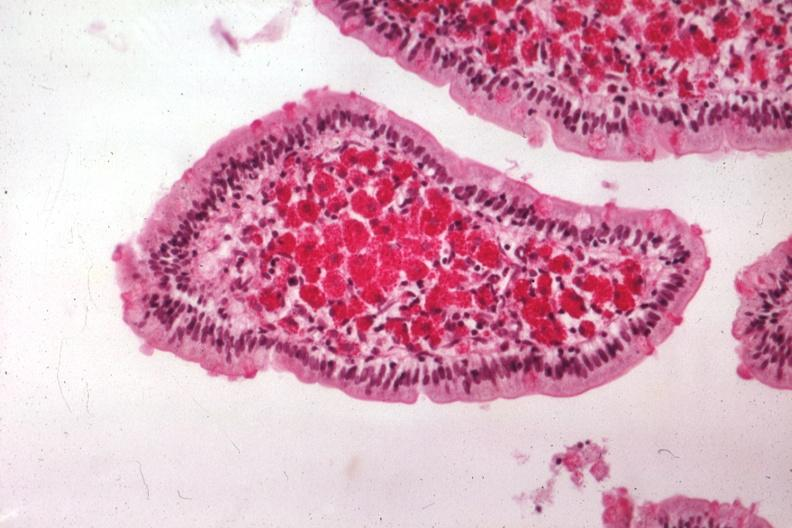s adenocarcinoma present?
Answer the question using a single word or phrase. No 